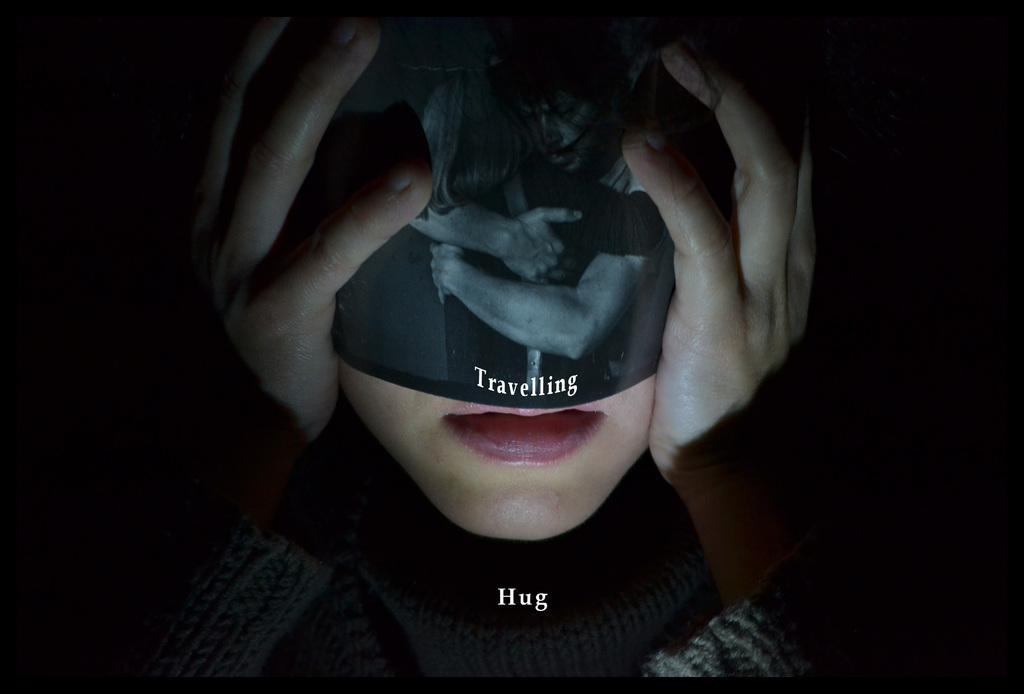Please provide a concise description of this image. In this image there is a woman, she is wearing an object, there is text on the object, there is text towards the bottom of the image, the background of the image is dark. 